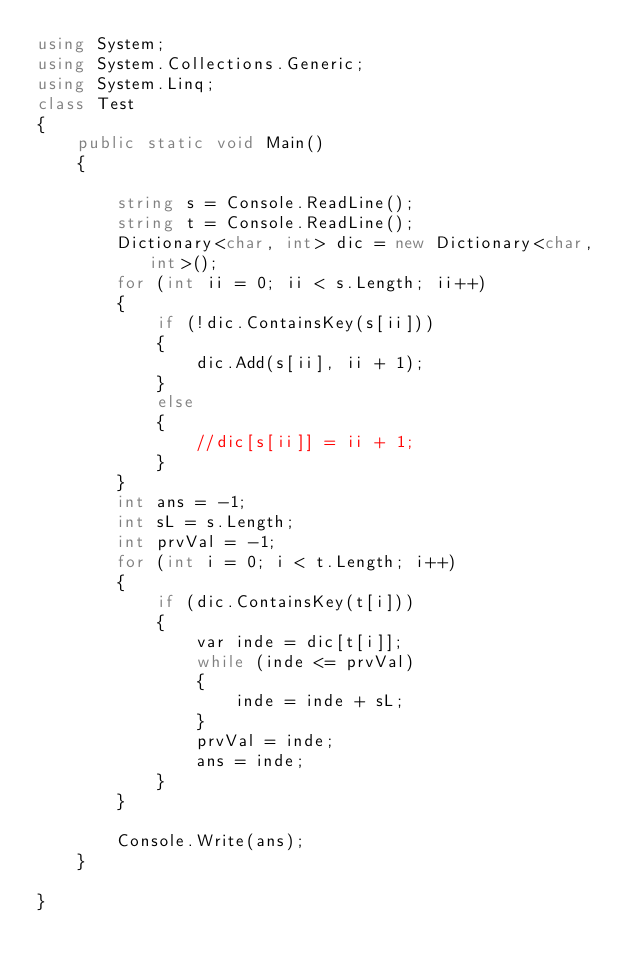Convert code to text. <code><loc_0><loc_0><loc_500><loc_500><_C#_>using System;
using System.Collections.Generic;
using System.Linq;
class Test
{
    public static void Main()
    {

        string s = Console.ReadLine();
        string t = Console.ReadLine();
        Dictionary<char, int> dic = new Dictionary<char, int>();
        for (int ii = 0; ii < s.Length; ii++)
        {
            if (!dic.ContainsKey(s[ii]))
            {
                dic.Add(s[ii], ii + 1);
            }
            else
            {
                //dic[s[ii]] = ii + 1;
            }
        }
        int ans = -1;
        int sL = s.Length;
        int prvVal = -1;
        for (int i = 0; i < t.Length; i++)
        {
            if (dic.ContainsKey(t[i]))
            {
                var inde = dic[t[i]];
                while (inde <= prvVal)
                {
                    inde = inde + sL;
                }
                prvVal = inde;
                ans = inde;
            }
        }

        Console.Write(ans);
    }

}


</code> 